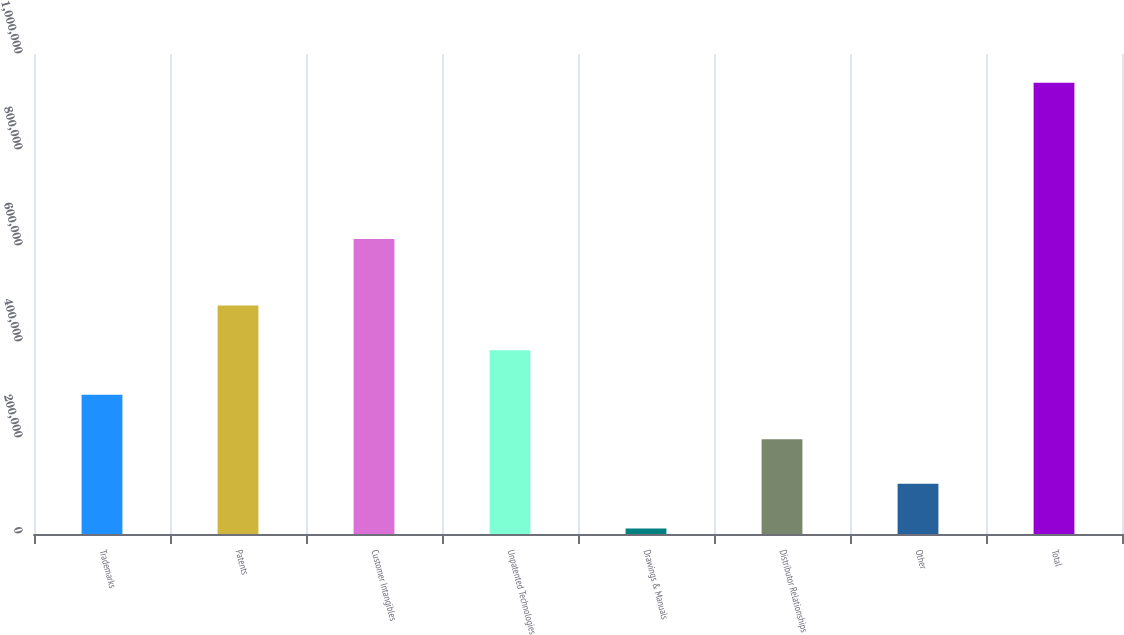<chart> <loc_0><loc_0><loc_500><loc_500><bar_chart><fcel>Trademarks<fcel>Patents<fcel>Customer Intangibles<fcel>Unpatented Technologies<fcel>Drawings & Manuals<fcel>Distributor Relationships<fcel>Other<fcel>Total<nl><fcel>290157<fcel>475805<fcel>614410<fcel>382981<fcel>11684<fcel>197332<fcel>104508<fcel>939926<nl></chart> 